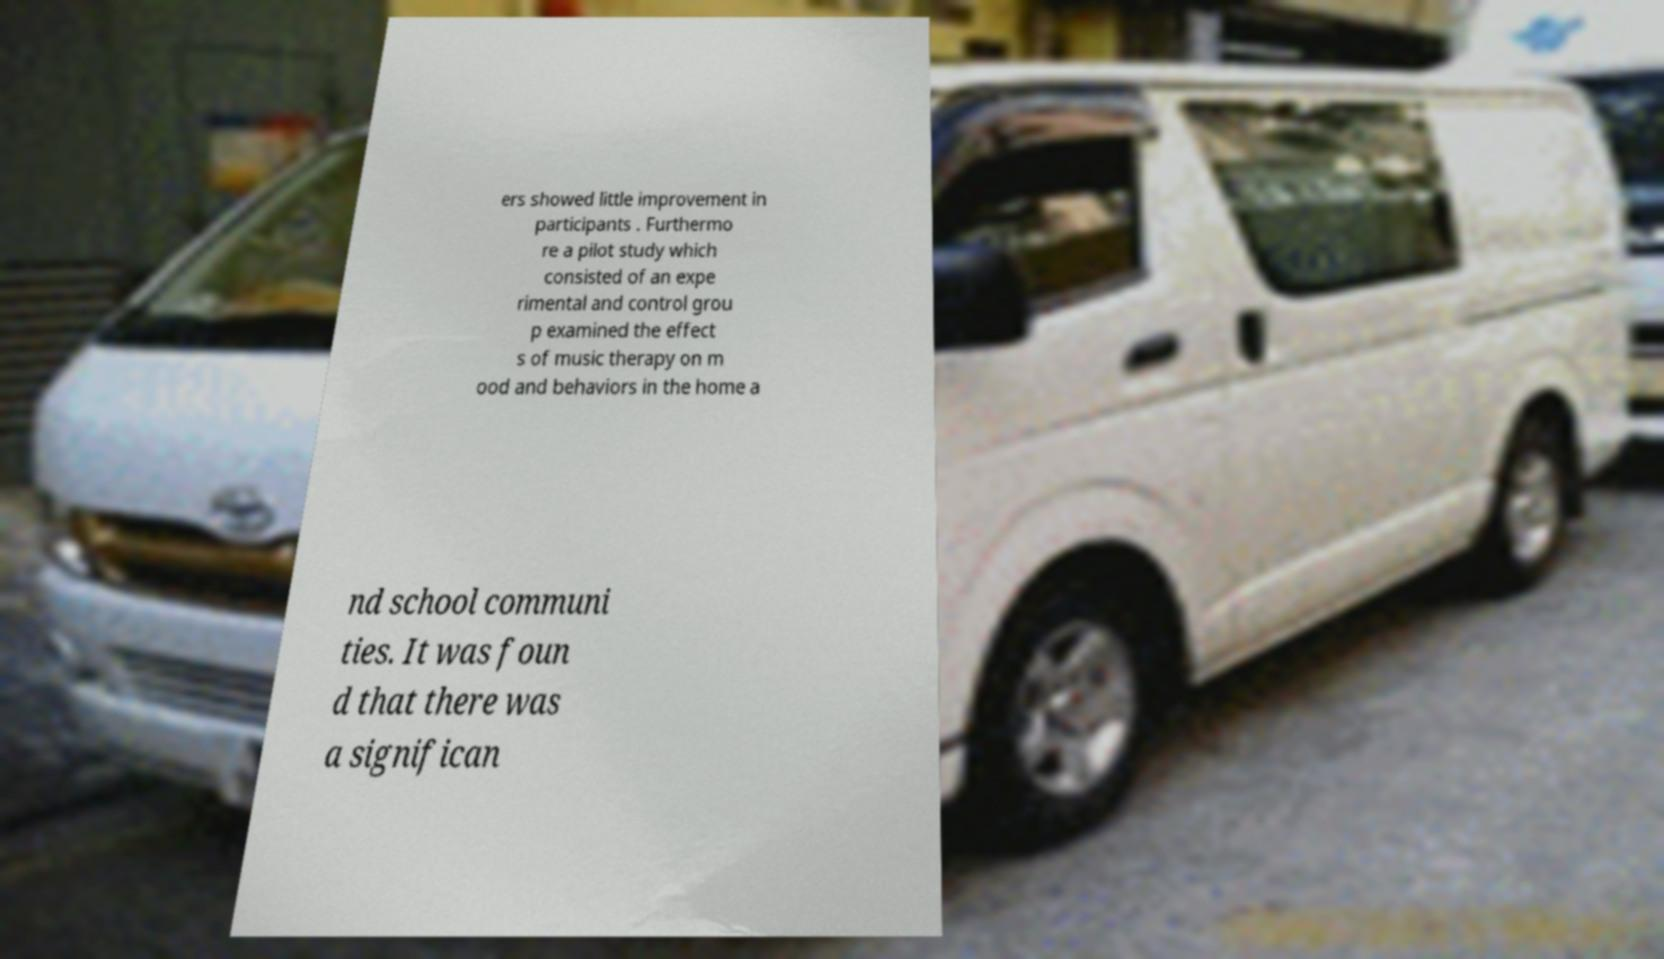For documentation purposes, I need the text within this image transcribed. Could you provide that? ers showed little improvement in participants . Furthermo re a pilot study which consisted of an expe rimental and control grou p examined the effect s of music therapy on m ood and behaviors in the home a nd school communi ties. It was foun d that there was a significan 